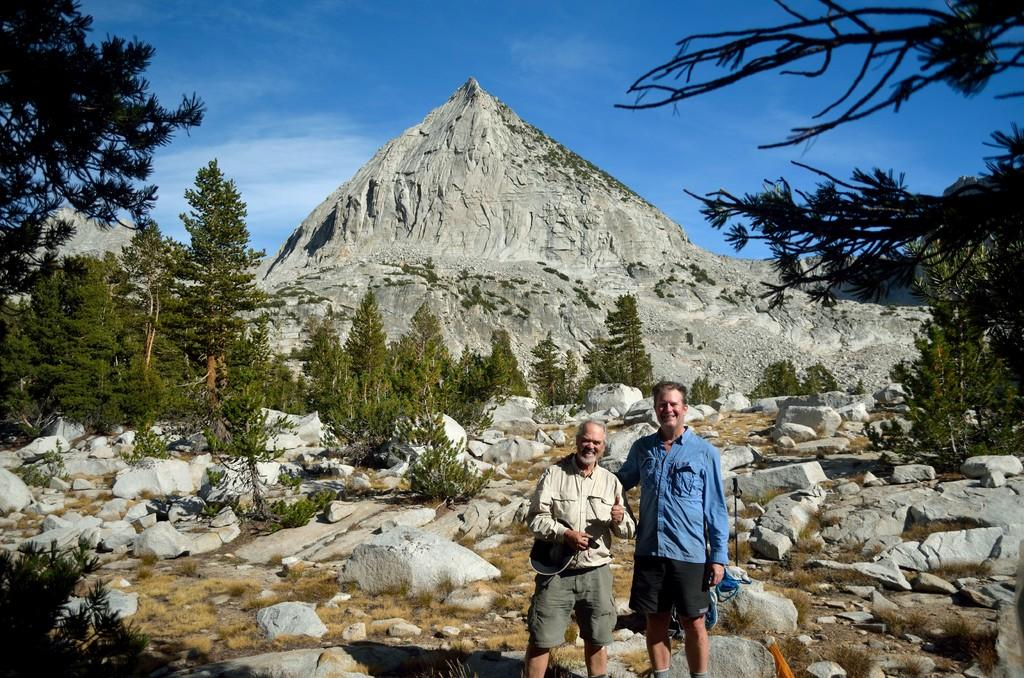How many people are in the image? There are two men in the image. What are the men doing in the image? The men are standing and smiling. What type of natural features can be seen in the image? There are rocks, trees, and hills visible in the image. Can you see a coil of wire in the image? There is no coil of wire present in the image. Is there a cart being pulled by a horse in the image? There is no cart or horse present in the image. 